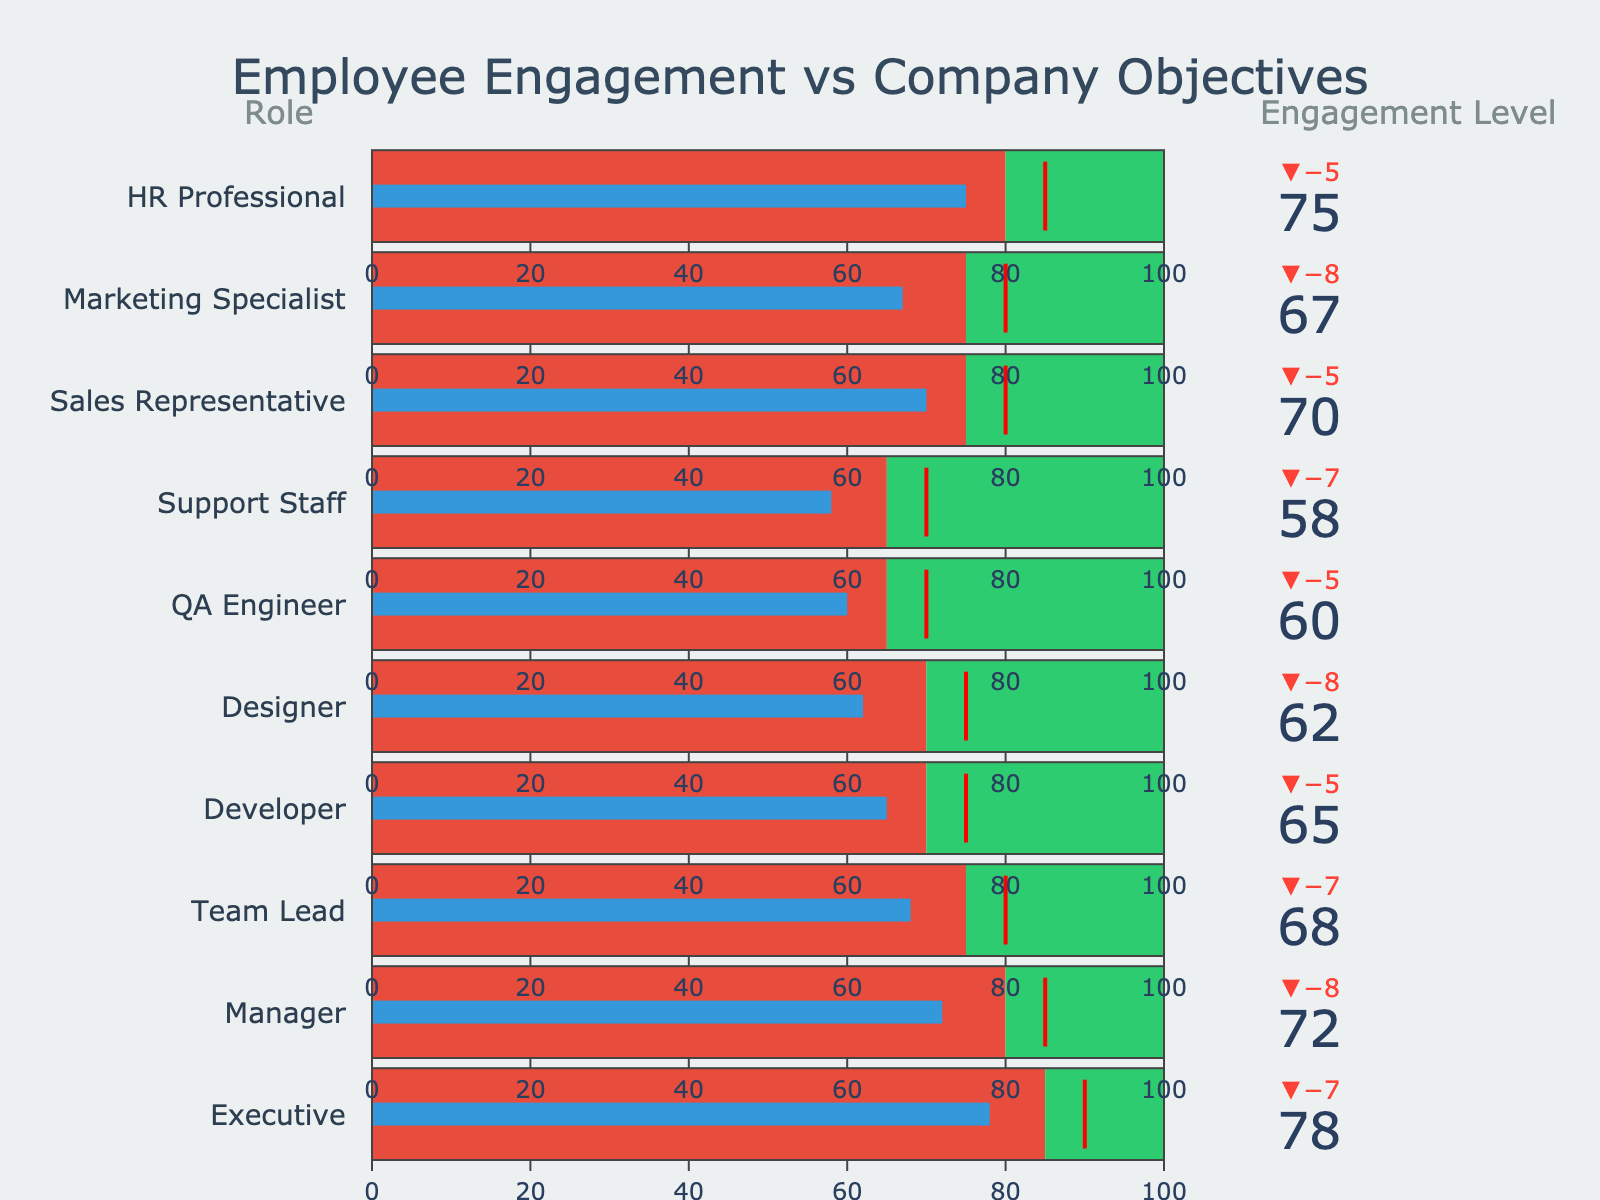What is the role with the highest actual engagement level? The highest actual engagement level can be identified by comparing the heights of the bullet bars across different roles.
Answer: Executive How does the actual engagement for Marketing Specialists compare to the target engagement level? Compare the actual engagement value for "Marketing Specialist" (67) with the target engagement value (75).
Answer: Below target What is the gap between the actual engagement and the company objective alignment for the HR Professional role? Subtract the actual engagement value for "HR Professional" (75) from the company objective alignment value (85).
Answer: 10 Which roles have a higher target engagement level than their actual engagement level? List the roles where the target engagement value is greater than the actual engagement value through comparison in each row.
Answer: Executive, Manager, Team Lead, Developer, Designer, QA Engineer, Support Staff, Sales Representative, Marketing Specialist For which role is the actual engagement closest to the company objective alignment? Calculate the absolute difference between the actual engagement and company objective alignment for each role and find the smallest difference.
Answer: Executive What is the difference in actual engagement between the Sales Representative and the Developer roles? Subtract the actual engagement value for "Developer" (65) from the actual engagement value for "Sales Representative" (70).
Answer: 5 Which role has the largest gap between actual engagement and target engagement? Subtract the actual engagement value from the target engagement value for each role and identify the largest difference.
Answer: Designer Are there any roles where the actual engagement meets or exceeds the company objective alignment? Check if any role's actual engagement value is greater than or equal to the company objective alignment.
Answer: No What is the total actual engagement summed across all roles? Add up all the actual engagement values for each role: 78 + 72 + 68 + 65 + 62 + 60 + 58 + 70 + 67 + 75.
Answer: 675 Which roles meet or exceed their target engagement? Identify the roles where the actual engagement value is greater than or equal to the target engagement value.
Answer: HR Professional 